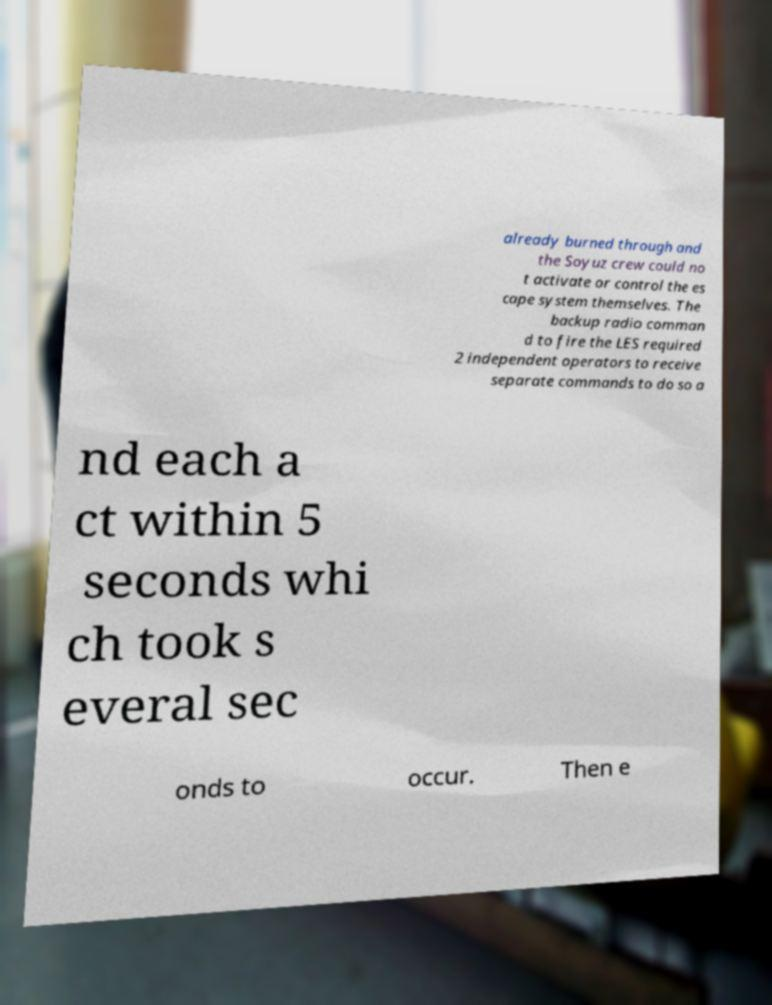Could you extract and type out the text from this image? already burned through and the Soyuz crew could no t activate or control the es cape system themselves. The backup radio comman d to fire the LES required 2 independent operators to receive separate commands to do so a nd each a ct within 5 seconds whi ch took s everal sec onds to occur. Then e 